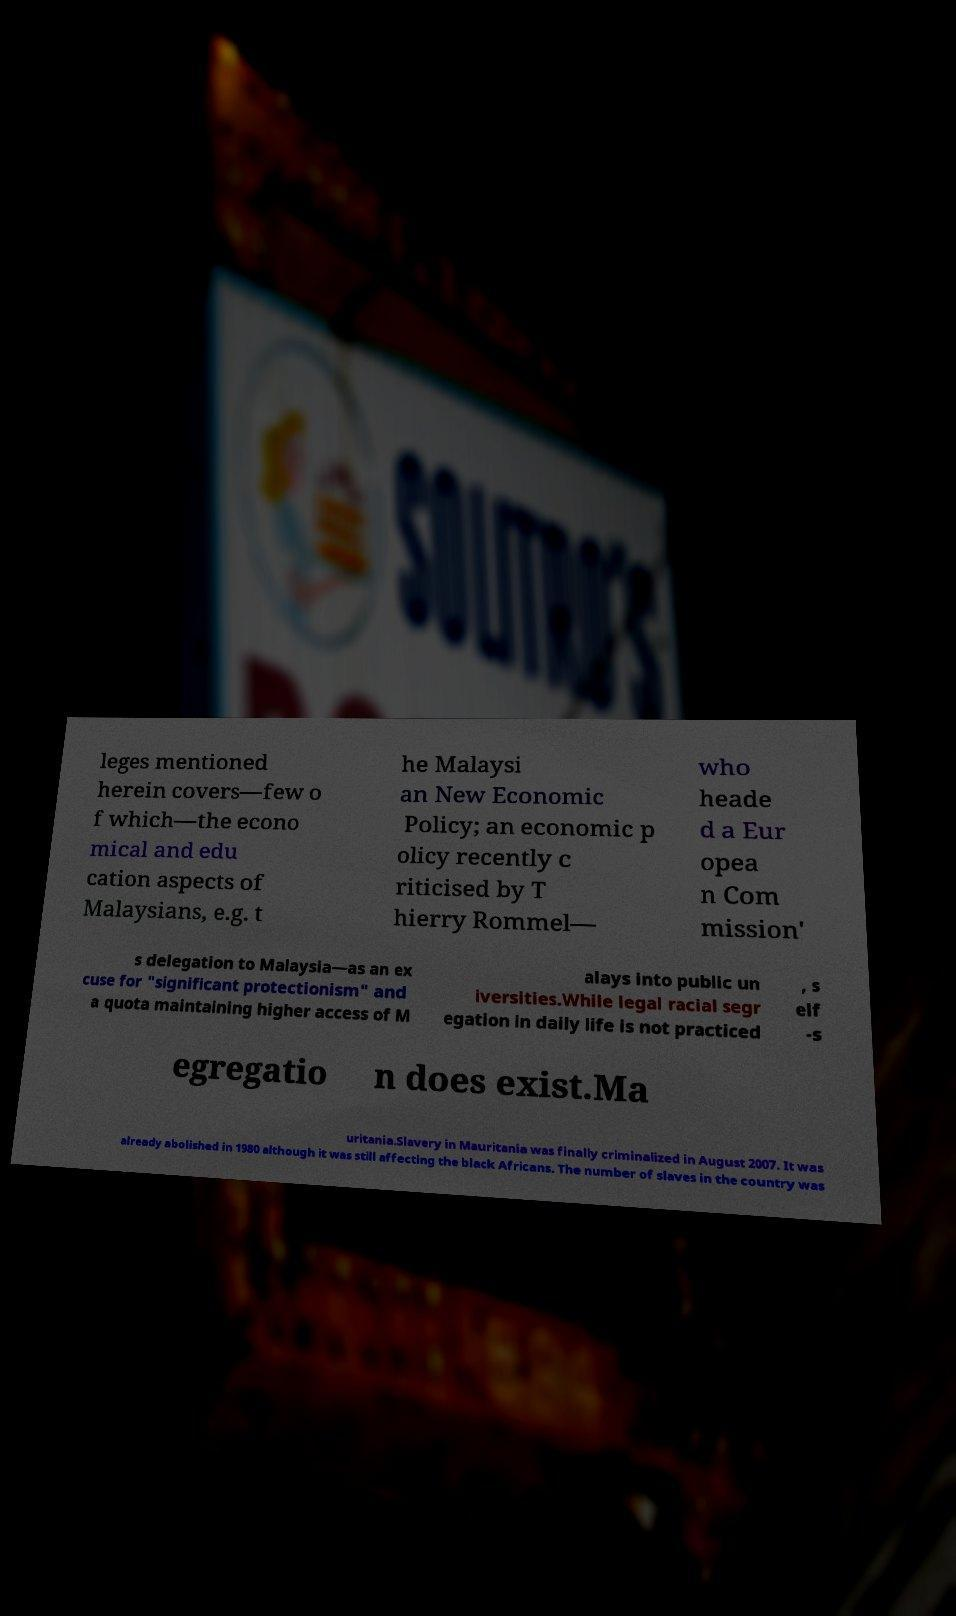Please read and relay the text visible in this image. What does it say? leges mentioned herein covers—few o f which—the econo mical and edu cation aspects of Malaysians, e.g. t he Malaysi an New Economic Policy; an economic p olicy recently c riticised by T hierry Rommel— who heade d a Eur opea n Com mission' s delegation to Malaysia—as an ex cuse for "significant protectionism" and a quota maintaining higher access of M alays into public un iversities.While legal racial segr egation in daily life is not practiced , s elf -s egregatio n does exist.Ma uritania.Slavery in Mauritania was finally criminalized in August 2007. It was already abolished in 1980 although it was still affecting the black Africans. The number of slaves in the country was 